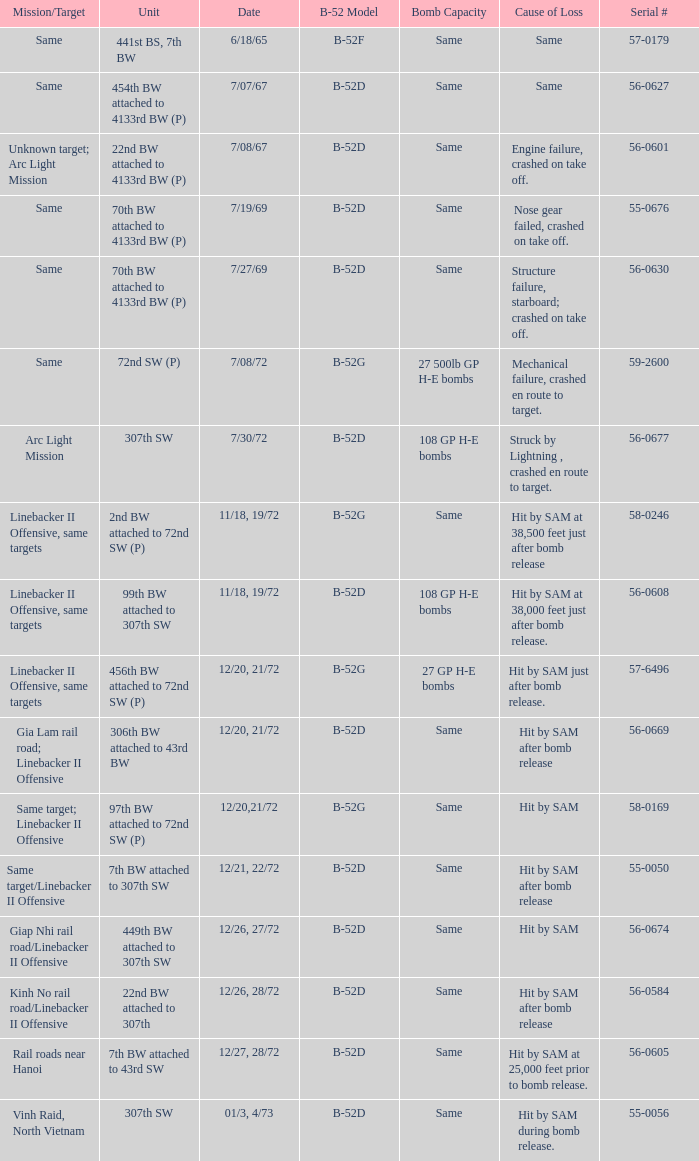When  27 gp h-e bombs the capacity of the bomb what is the cause of loss? Hit by SAM just after bomb release. 